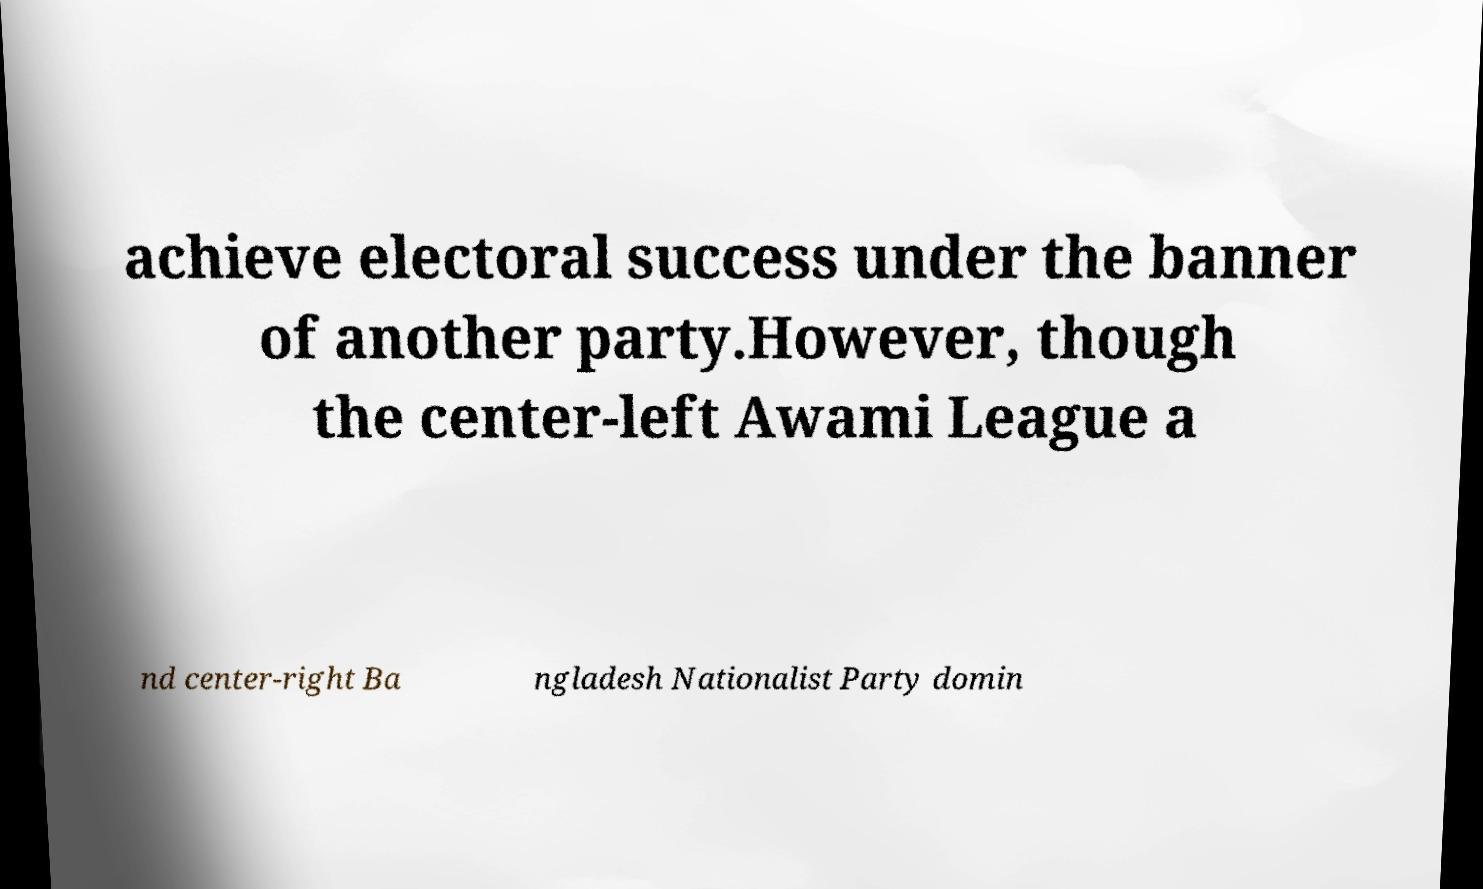Could you assist in decoding the text presented in this image and type it out clearly? achieve electoral success under the banner of another party.However, though the center-left Awami League a nd center-right Ba ngladesh Nationalist Party domin 